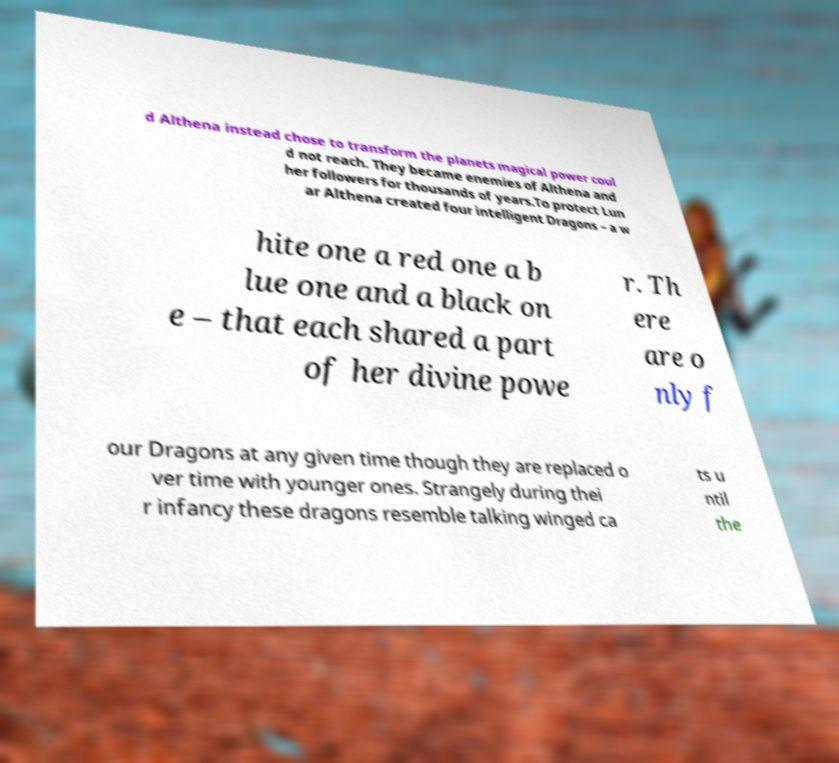Can you accurately transcribe the text from the provided image for me? d Althena instead chose to transform the planets magical power coul d not reach. They became enemies of Althena and her followers for thousands of years.To protect Lun ar Althena created four intelligent Dragons – a w hite one a red one a b lue one and a black on e – that each shared a part of her divine powe r. Th ere are o nly f our Dragons at any given time though they are replaced o ver time with younger ones. Strangely during thei r infancy these dragons resemble talking winged ca ts u ntil the 